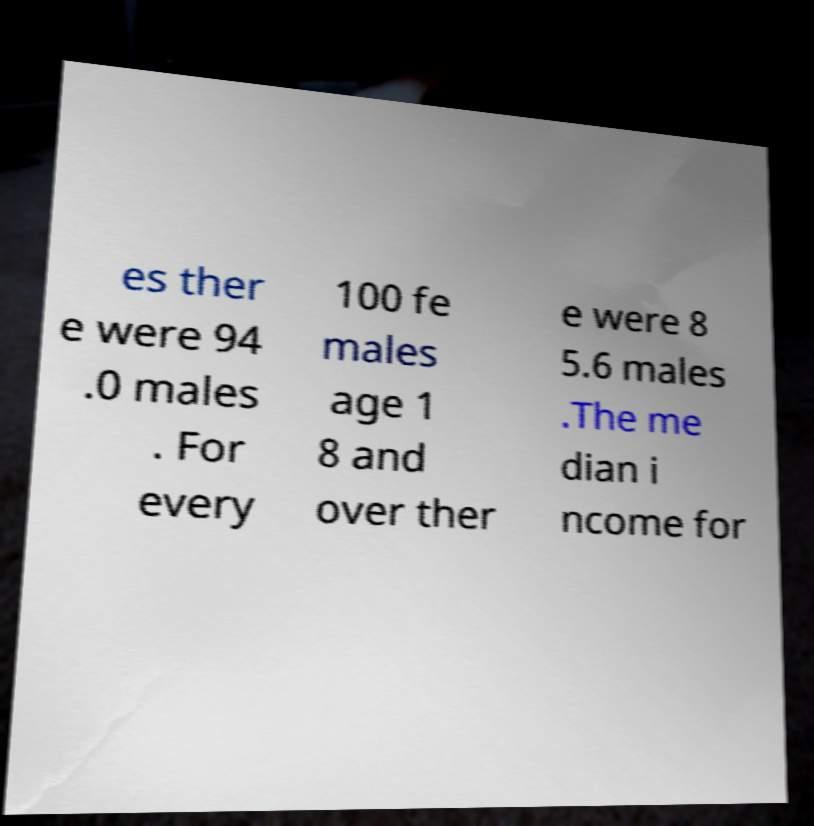Can you accurately transcribe the text from the provided image for me? es ther e were 94 .0 males . For every 100 fe males age 1 8 and over ther e were 8 5.6 males .The me dian i ncome for 